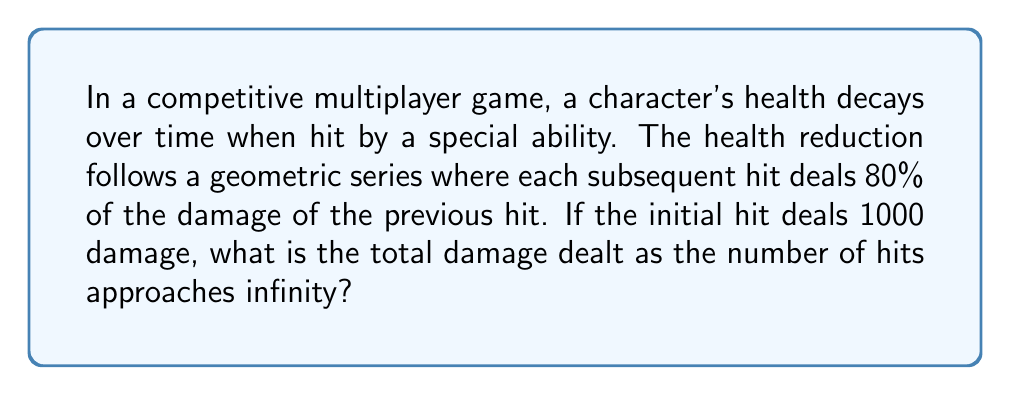Can you solve this math problem? Let's approach this step-by-step:

1) The geometric series for the damage can be written as:

   $$S_{\infty} = 1000 + 1000(0.8) + 1000(0.8)^2 + 1000(0.8)^3 + ...$$

2) This is a geometric series with first term $a = 1000$ and common ratio $r = 0.8$

3) For an infinite geometric series with $|r| < 1$, the sum is given by the formula:

   $$S_{\infty} = \frac{a}{1-r}$$

4) In this case, $|r| = 0.8 < 1$, so we can use this formula.

5) Substituting our values:

   $$S_{\infty} = \frac{1000}{1-0.8} = \frac{1000}{0.2}$$

6) Simplifying:

   $$S_{\infty} = 5000$$

Therefore, as the number of hits approaches infinity, the total damage dealt approaches 5000.
Answer: 5000 